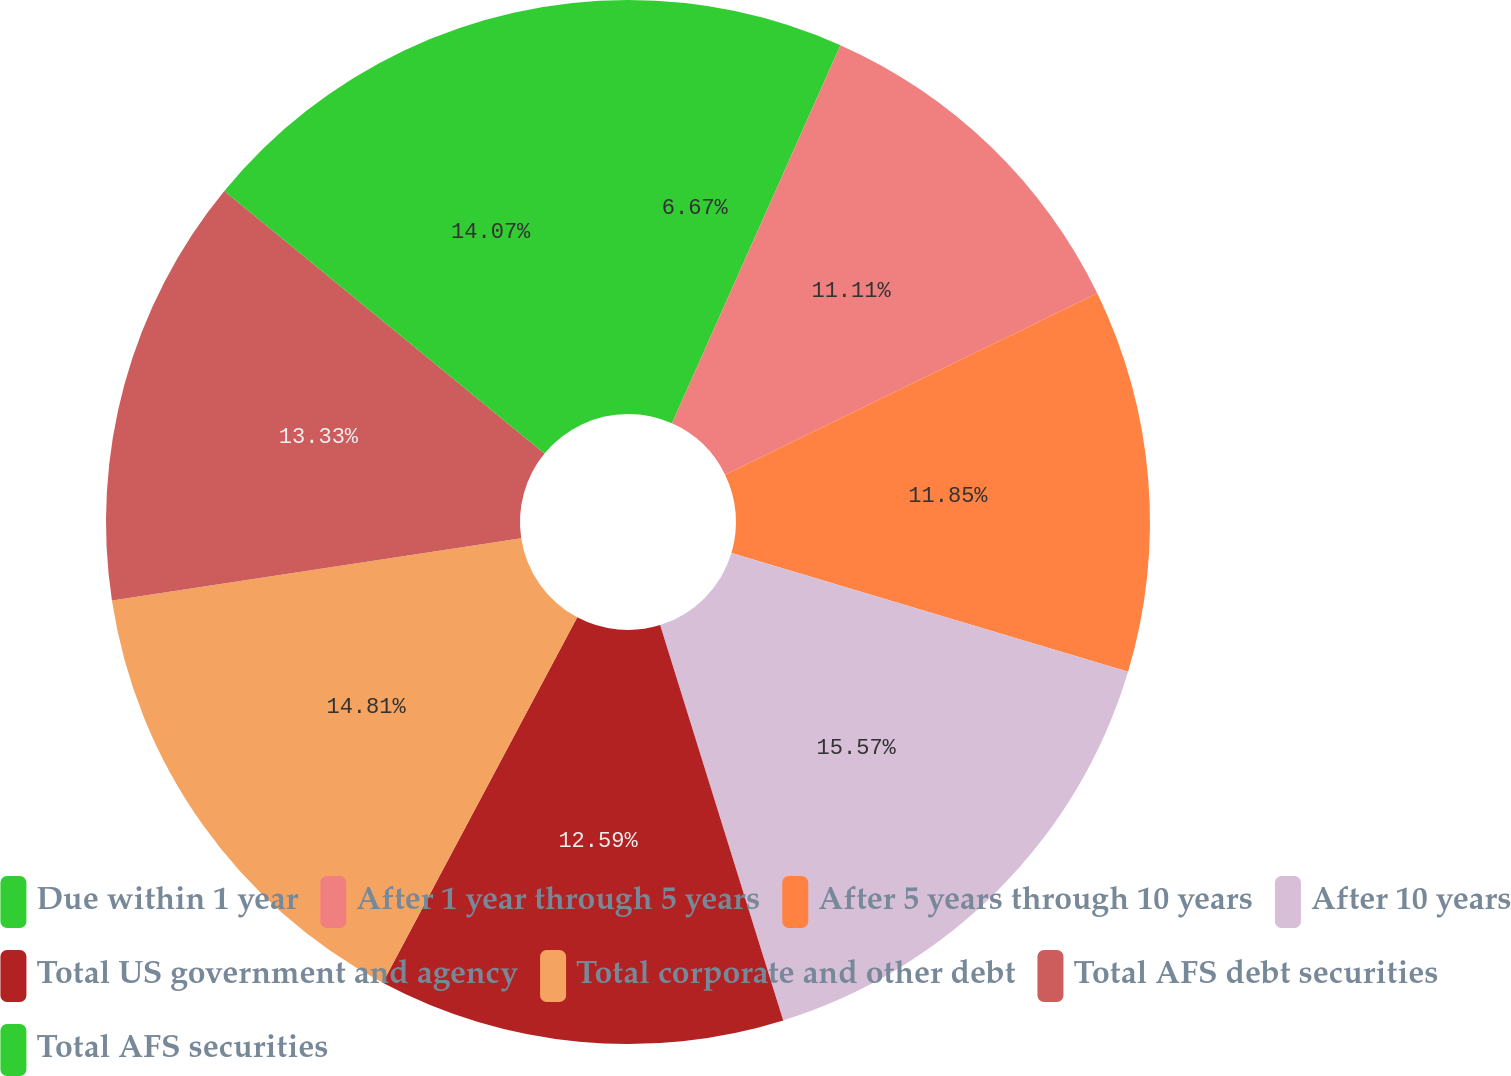Convert chart. <chart><loc_0><loc_0><loc_500><loc_500><pie_chart><fcel>Due within 1 year<fcel>After 1 year through 5 years<fcel>After 5 years through 10 years<fcel>After 10 years<fcel>Total US government and agency<fcel>Total corporate and other debt<fcel>Total AFS debt securities<fcel>Total AFS securities<nl><fcel>6.67%<fcel>11.11%<fcel>11.85%<fcel>15.56%<fcel>12.59%<fcel>14.81%<fcel>13.33%<fcel>14.07%<nl></chart> 